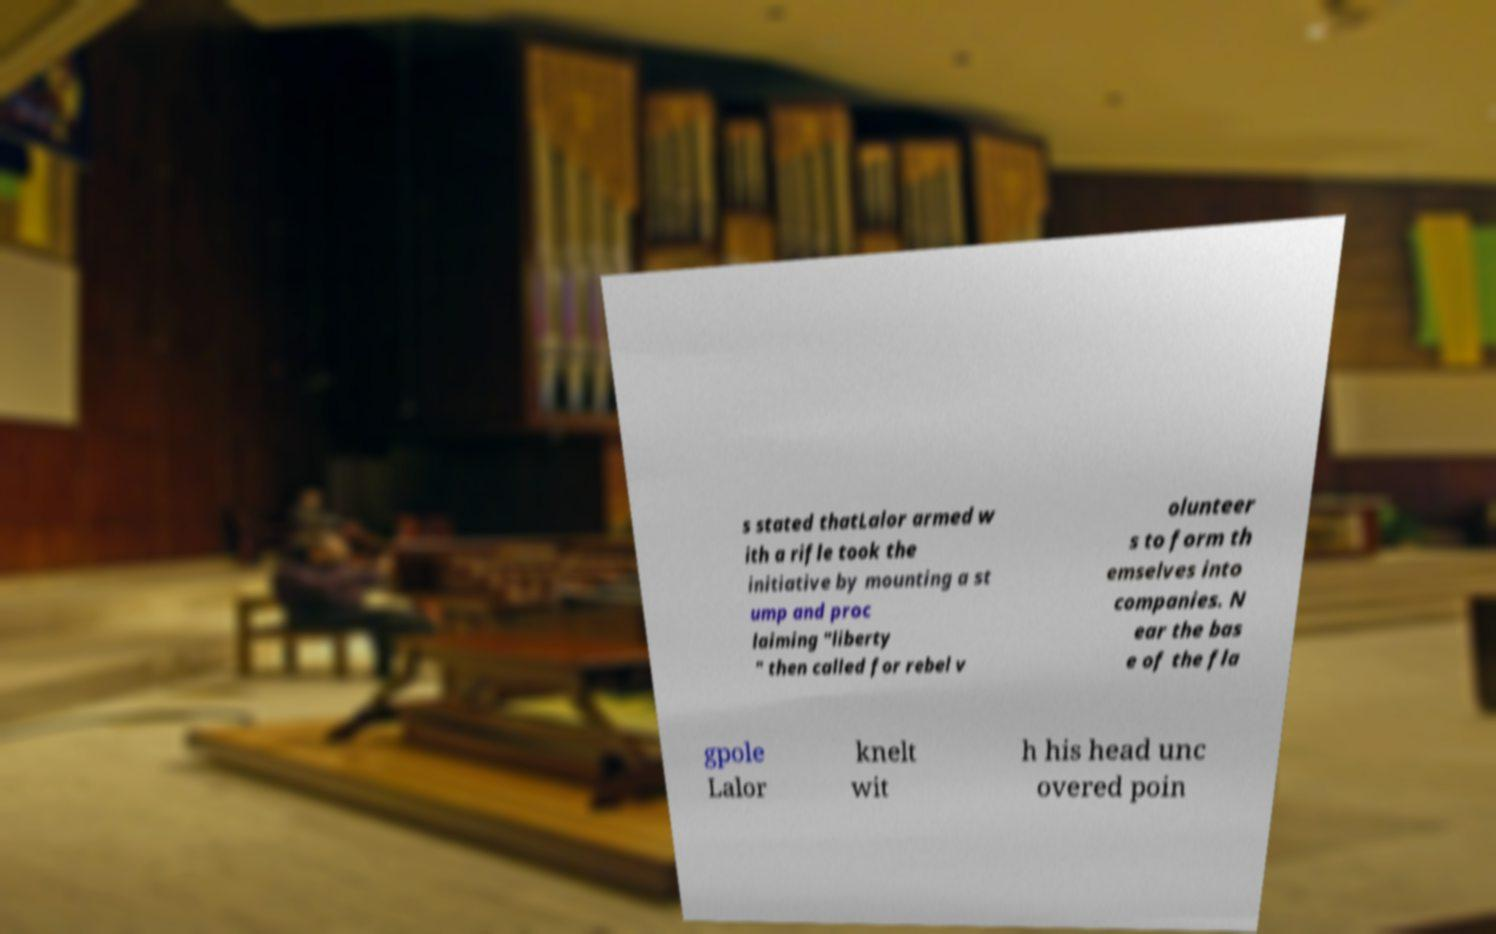Could you extract and type out the text from this image? s stated thatLalor armed w ith a rifle took the initiative by mounting a st ump and proc laiming "liberty " then called for rebel v olunteer s to form th emselves into companies. N ear the bas e of the fla gpole Lalor knelt wit h his head unc overed poin 